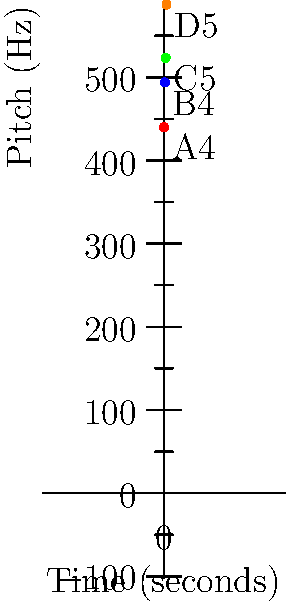In the coordinate plane above, musical notes are plotted with time (in seconds) on the x-axis and pitch (in Hz) on the y-axis. If a new note E5 with a frequency of 659.25 Hz is played at 4 seconds, what would be its coordinates on this plane? To determine the coordinates of the new note E5, we need to follow these steps:

1. Identify the x-coordinate:
   - The x-axis represents time in seconds.
   - The question states that E5 is played at 4 seconds.
   - Therefore, the x-coordinate is 4.

2. Identify the y-coordinate:
   - The y-axis represents pitch in Hz (Hertz).
   - The question gives us the frequency of E5 as 659.25 Hz.
   - Therefore, the y-coordinate is 659.25.

3. Combine the x and y coordinates:
   - The coordinates are represented as an ordered pair (x, y).
   - In this case, it would be (4, 659.25).

Thus, the coordinates of the new note E5 on this plane would be (4, 659.25).
Answer: $(4, 659.25)$ 